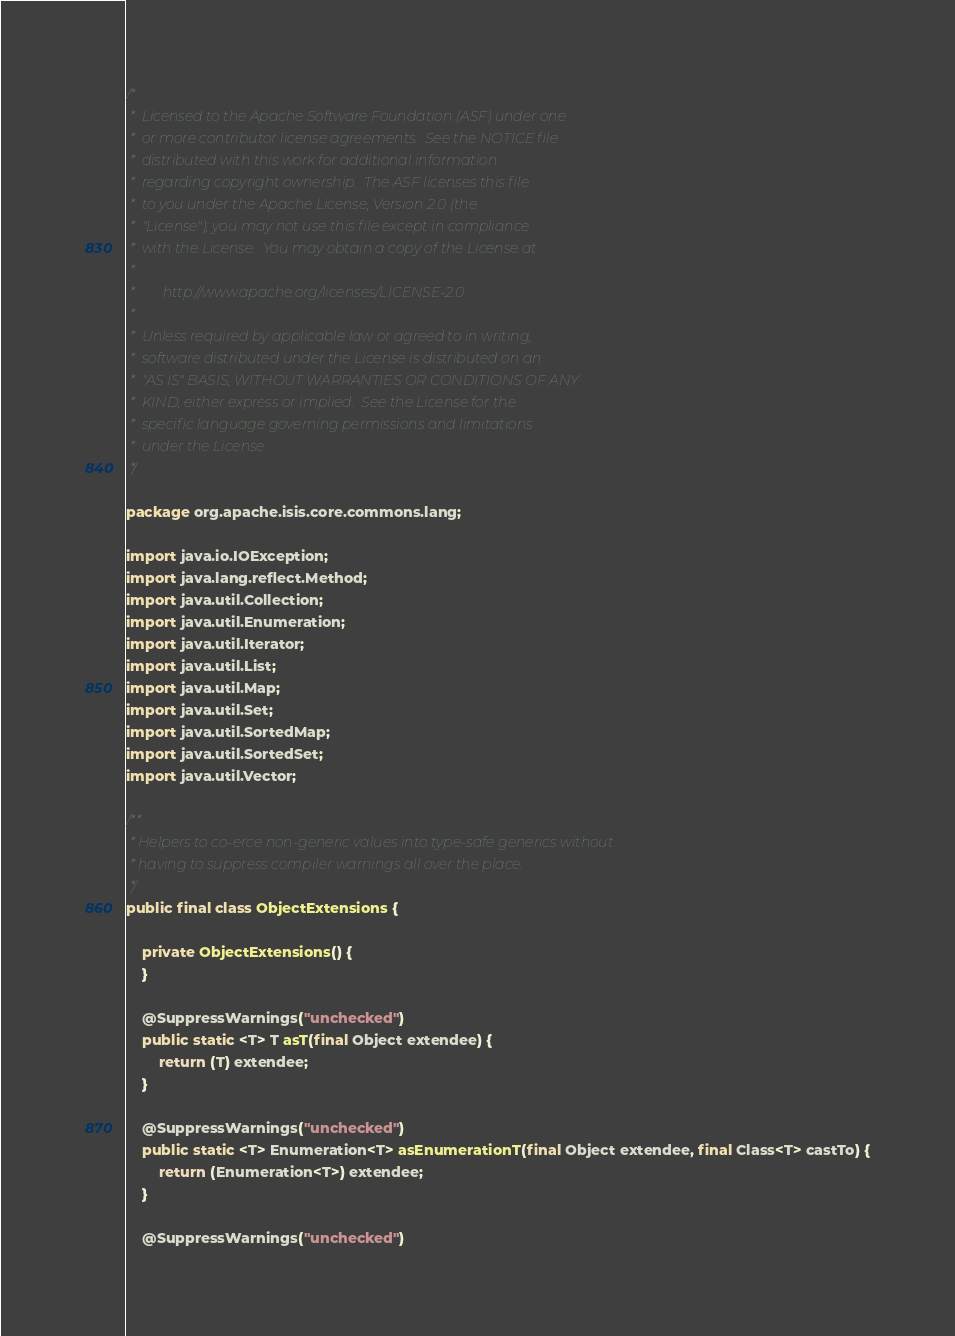Convert code to text. <code><loc_0><loc_0><loc_500><loc_500><_Java_>/*
 *  Licensed to the Apache Software Foundation (ASF) under one
 *  or more contributor license agreements.  See the NOTICE file
 *  distributed with this work for additional information
 *  regarding copyright ownership.  The ASF licenses this file
 *  to you under the Apache License, Version 2.0 (the
 *  "License"); you may not use this file except in compliance
 *  with the License.  You may obtain a copy of the License at
 *
 *        http://www.apache.org/licenses/LICENSE-2.0
 *
 *  Unless required by applicable law or agreed to in writing,
 *  software distributed under the License is distributed on an
 *  "AS IS" BASIS, WITHOUT WARRANTIES OR CONDITIONS OF ANY
 *  KIND, either express or implied.  See the License for the
 *  specific language governing permissions and limitations
 *  under the License.
 */

package org.apache.isis.core.commons.lang;

import java.io.IOException;
import java.lang.reflect.Method;
import java.util.Collection;
import java.util.Enumeration;
import java.util.Iterator;
import java.util.List;
import java.util.Map;
import java.util.Set;
import java.util.SortedMap;
import java.util.SortedSet;
import java.util.Vector;

/**
 * Helpers to co-erce non-generic values into type-safe generics without
 * having to suppress compiler warnings all over the place.
 */
public final class ObjectExtensions {

    private ObjectExtensions() {
    }

    @SuppressWarnings("unchecked")
    public static <T> T asT(final Object extendee) {
        return (T) extendee;
    }

    @SuppressWarnings("unchecked")
    public static <T> Enumeration<T> asEnumerationT(final Object extendee, final Class<T> castTo) {
        return (Enumeration<T>) extendee;
    }

    @SuppressWarnings("unchecked")</code> 